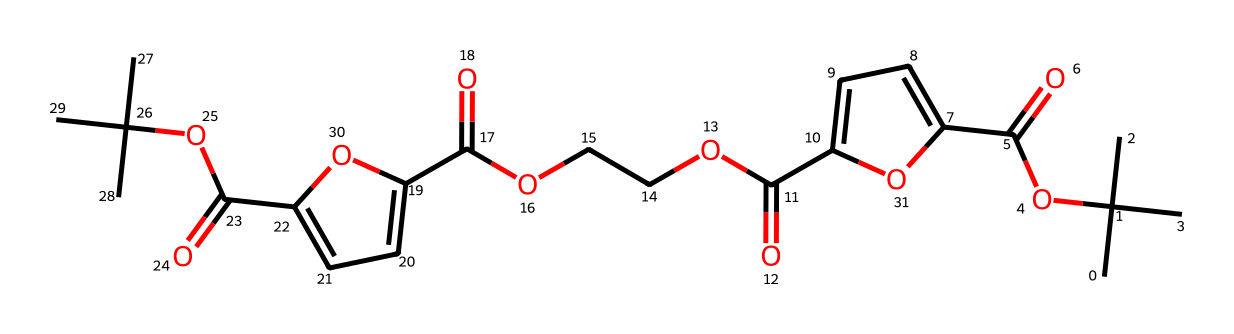How many carbon atoms are present in the structure of polyethylene furanoate (PEF)? To determine the number of carbon atoms, I will analyze the SMILES representation for occurrences of the carbon atom symbol (C). I can count the C symbols in the provided SMILES string. After counting, I find there are 17 carbon atoms in total.
Answer: 17 What functional groups are present in polyethylene furanoate (PEF)? I will examine the structure represented by the SMILES notation for characteristic functional groups. In this compound, I identify ester groups (–COOC–) and carboxylic acids (–COOH) based on the presence of carbonyl (C=O) followed by an oxygen (O) or hydroxyl (–OH) groups. Thus, the primary groups identified are esters and carboxylic acids.
Answer: esters and carboxylic acids What type of polymer is polyethylene furanoate (PEF)? To classify this substance, I consider its structure and compare it to known polymer types. PEF, being derived from bio-based materials and sharing similarities with polyethylene terephthalate (PET) in structure, categorizes it as a biopolymer.
Answer: biopolymer What is the degree of unsaturation in the structure of polyethylene furanoate (PEF)? The degree of unsaturation can be calculated by considering the number of rings and multiple bonds present (like double bonds). Throughout the SMILES structure, I identify various double bonds indicating calculated unsaturation. For PEF, analyzing its structure reveals two degrees of unsaturation.
Answer: 2 How many ester linkages are present in polyethylene furanoate (PEF)? I can identify ester linkages by locating the –COOC– fragments within the SMILES representation. After examining the structure, I find that there are three ester linkages in total present in PEF.
Answer: 3 Is polyethylene furanoate (PEF) a biodegradable plastic? To determine if PEF is biodegradable, I will consider its bio-based origin and the properties of its polymer structure, which generally allow for microbial degradation. Since PEF is derived from renewable resources, it is known to exhibit biodegradability in suitable conditions.
Answer: yes 